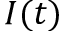<formula> <loc_0><loc_0><loc_500><loc_500>I ( t )</formula> 